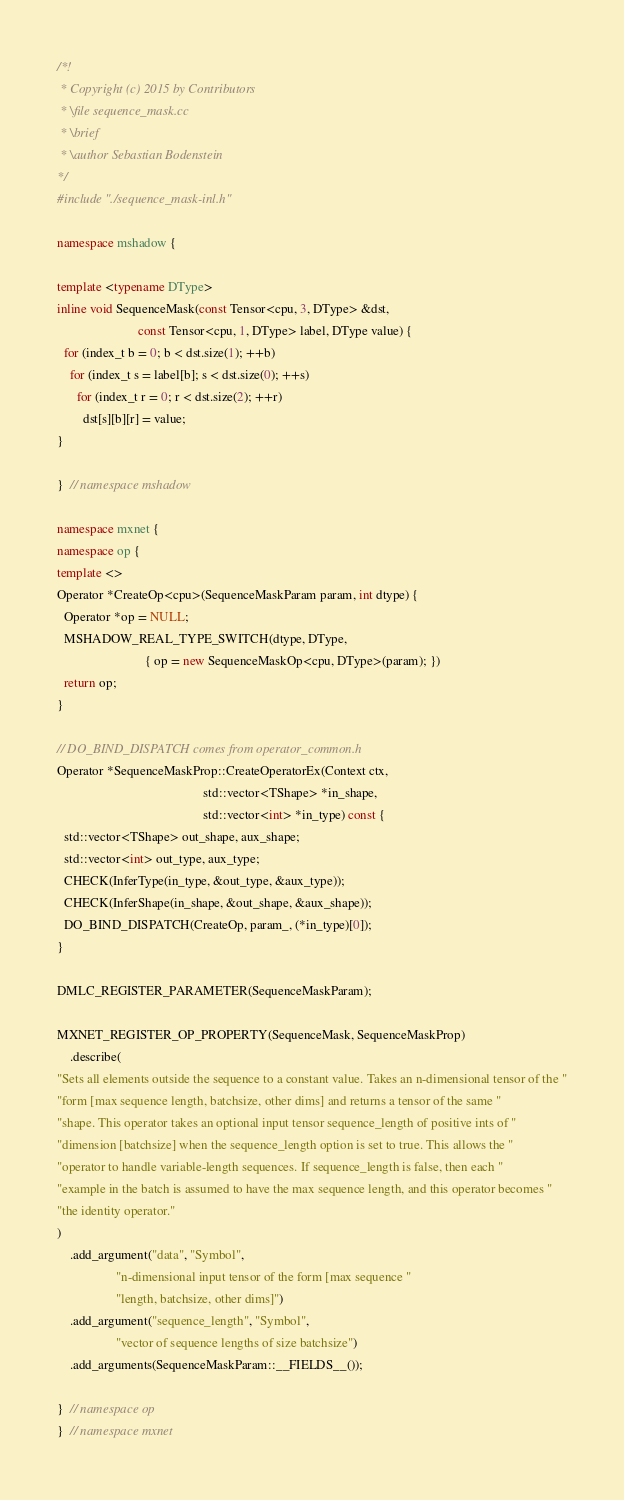Convert code to text. <code><loc_0><loc_0><loc_500><loc_500><_C++_>/*!
 * Copyright (c) 2015 by Contributors
 * \file sequence_mask.cc
 * \brief
 * \author Sebastian Bodenstein
*/
#include "./sequence_mask-inl.h"

namespace mshadow {

template <typename DType>
inline void SequenceMask(const Tensor<cpu, 3, DType> &dst,
                         const Tensor<cpu, 1, DType> label, DType value) {
  for (index_t b = 0; b < dst.size(1); ++b)
    for (index_t s = label[b]; s < dst.size(0); ++s)
      for (index_t r = 0; r < dst.size(2); ++r)
        dst[s][b][r] = value;
}

}  // namespace mshadow

namespace mxnet {
namespace op {
template <>
Operator *CreateOp<cpu>(SequenceMaskParam param, int dtype) {
  Operator *op = NULL;
  MSHADOW_REAL_TYPE_SWITCH(dtype, DType,
                           { op = new SequenceMaskOp<cpu, DType>(param); })
  return op;
}

// DO_BIND_DISPATCH comes from operator_common.h
Operator *SequenceMaskProp::CreateOperatorEx(Context ctx,
                                             std::vector<TShape> *in_shape,
                                             std::vector<int> *in_type) const {
  std::vector<TShape> out_shape, aux_shape;
  std::vector<int> out_type, aux_type;
  CHECK(InferType(in_type, &out_type, &aux_type));
  CHECK(InferShape(in_shape, &out_shape, &aux_shape));
  DO_BIND_DISPATCH(CreateOp, param_, (*in_type)[0]);
}

DMLC_REGISTER_PARAMETER(SequenceMaskParam);

MXNET_REGISTER_OP_PROPERTY(SequenceMask, SequenceMaskProp)
    .describe(
"Sets all elements outside the sequence to a constant value. Takes an n-dimensional tensor of the "
"form [max sequence length, batchsize, other dims] and returns a tensor of the same "
"shape. This operator takes an optional input tensor sequence_length of positive ints of "
"dimension [batchsize] when the sequence_length option is set to true. This allows the "
"operator to handle variable-length sequences. If sequence_length is false, then each "
"example in the batch is assumed to have the max sequence length, and this operator becomes "
"the identity operator."
)
    .add_argument("data", "Symbol",
                  "n-dimensional input tensor of the form [max sequence "
                  "length, batchsize, other dims]")
    .add_argument("sequence_length", "Symbol",
                  "vector of sequence lengths of size batchsize")
    .add_arguments(SequenceMaskParam::__FIELDS__());

}  // namespace op
}  // namespace mxnet
</code> 